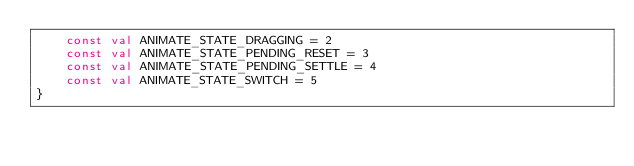Convert code to text. <code><loc_0><loc_0><loc_500><loc_500><_Kotlin_>    const val ANIMATE_STATE_DRAGGING = 2
    const val ANIMATE_STATE_PENDING_RESET = 3
    const val ANIMATE_STATE_PENDING_SETTLE = 4
    const val ANIMATE_STATE_SWITCH = 5
}</code> 